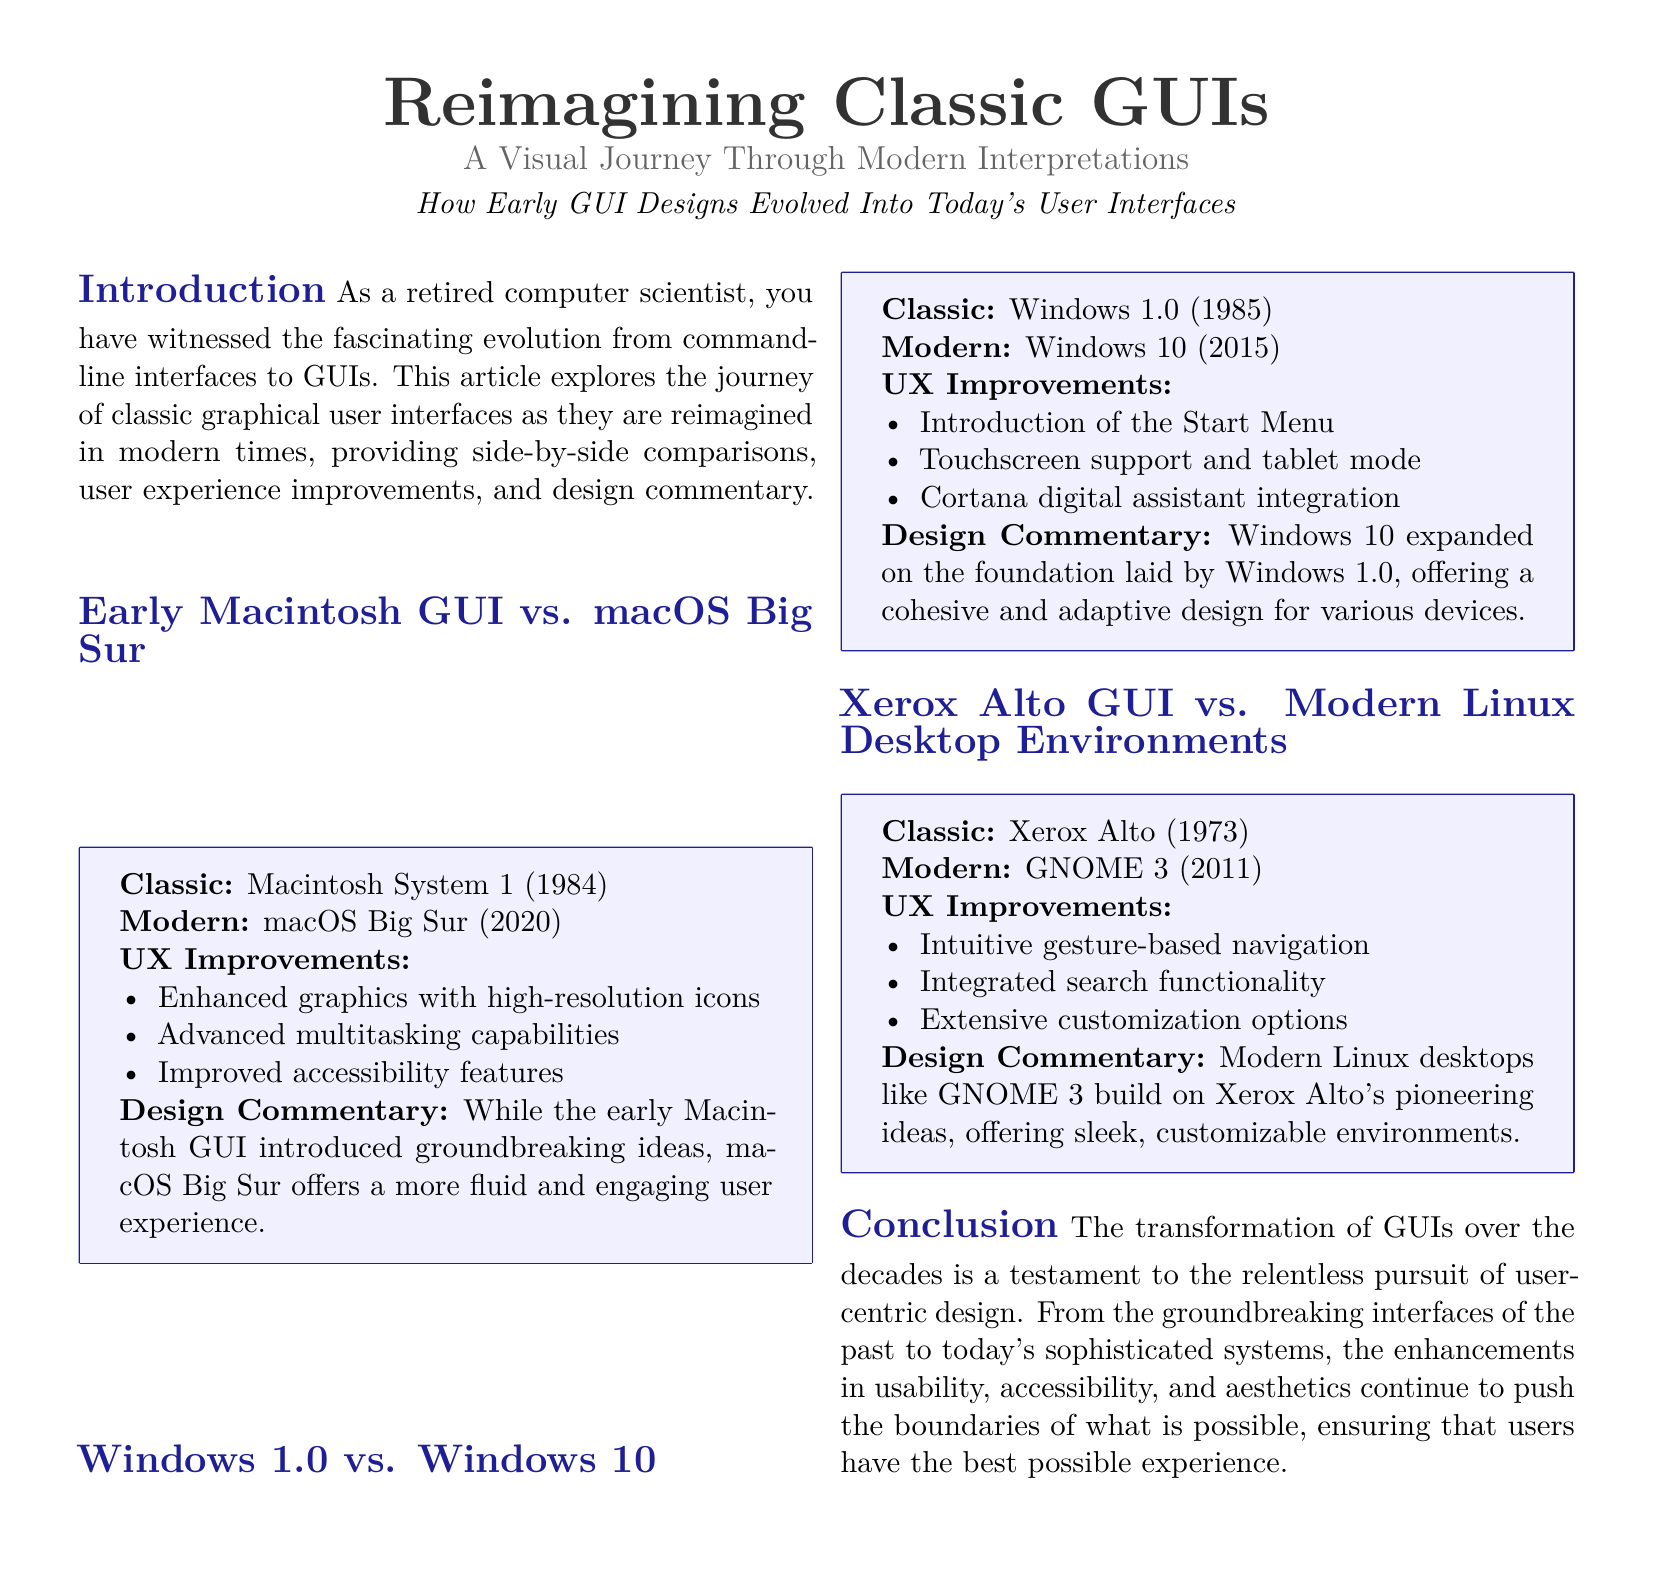What year was the classic Macintosh GUI released? The classic Macintosh GUI was released in 1984, as stated in the comparison box.
Answer: 1984 What modern OS is compared to Macintosh System 1? The modern OS compared to Macintosh System 1 is macOS Big Sur, mentioned in the section header.
Answer: macOS Big Sur What is one UX improvement noted for Windows 10? One UX improvement noted for Windows 10 is the introduction of the Start Menu, listed under UX Improvements.
Answer: Start Menu How many UX improvements are listed for the Xerox Alto GUI? There are three UX improvements listed for the Xerox Alto GUI in the corresponding comparison box.
Answer: 3 What does the design commentary say about macOS Big Sur? The design commentary states that macOS Big Sur offers a more fluid and engaging user experience, from the design commentary section.
Answer: fluid and engaging user experience Which early GUI is noted for pioneering ideas? The Xerox Alto GUI is noted for pioneering ideas, as stated in the corresponding comparison box.
Answer: Xerox Alto What feature does GNOME 3 offer regarding navigation? GNOME 3 offers intuitive gesture-based navigation, as mentioned in the UX Improvements section.
Answer: intuitive gesture-based navigation How many sections are included in the magazine layout? The magazine layout includes five sections, as outlined in the document structure.
Answer: 5 